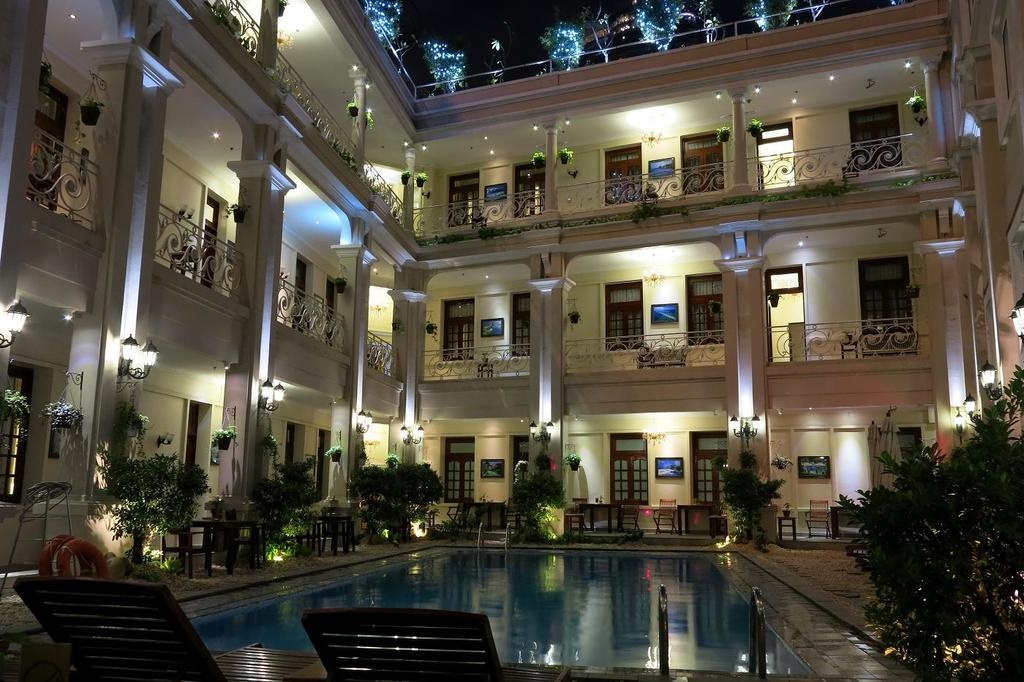What type of furniture can be seen in the image? There are chairs in the image. What is the main outdoor feature in the image? There is a swimming pool in the image. What type of vegetation is present in the image? There are trees in the image. What type of indoor plants can be seen in the image? There are house plants in the image. What type of surface can be used for placing objects in the image? There are tables in the image. What type of swimming aid is present in the image? There are swim tubes in the image. What type of decorative items can be seen on the walls in the image? There are frames on the wall in the image. What type of architectural feature can be seen in the image? There are pillars in the image. What type of structure is visible in the image? There is a building with windows in the image. What other objects can be seen in the image? There are some objects in the image. How does the ant say good-bye to the yard in the image? There is no ant present in the image, and therefore no such interaction can be observed. What type of yard is visible in the image? The image does not show a yard; it features a swimming pool, trees, and other elements. 